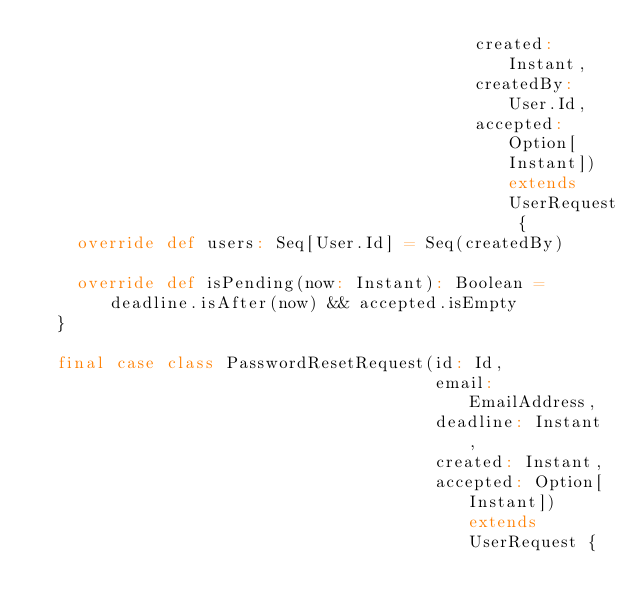Convert code to text. <code><loc_0><loc_0><loc_500><loc_500><_Scala_>                                            created: Instant,
                                            createdBy: User.Id,
                                            accepted: Option[Instant]) extends UserRequest {
    override def users: Seq[User.Id] = Seq(createdBy)

    override def isPending(now: Instant): Boolean = deadline.isAfter(now) && accepted.isEmpty
  }

  final case class PasswordResetRequest(id: Id,
                                        email: EmailAddress,
                                        deadline: Instant,
                                        created: Instant,
                                        accepted: Option[Instant]) extends UserRequest {</code> 